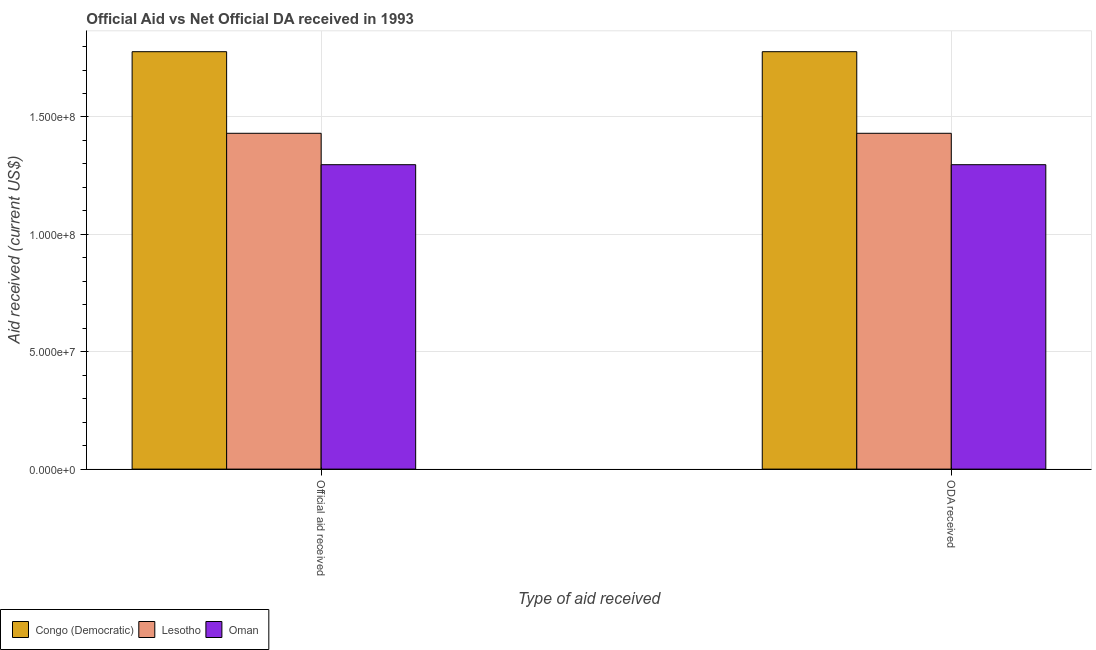How many different coloured bars are there?
Ensure brevity in your answer.  3. Are the number of bars on each tick of the X-axis equal?
Keep it short and to the point. Yes. How many bars are there on the 1st tick from the right?
Your response must be concise. 3. What is the label of the 1st group of bars from the left?
Your response must be concise. Official aid received. What is the official aid received in Oman?
Ensure brevity in your answer.  1.30e+08. Across all countries, what is the maximum oda received?
Give a very brief answer. 1.78e+08. Across all countries, what is the minimum oda received?
Keep it short and to the point. 1.30e+08. In which country was the oda received maximum?
Provide a short and direct response. Congo (Democratic). In which country was the official aid received minimum?
Your answer should be compact. Oman. What is the total oda received in the graph?
Your answer should be very brief. 4.51e+08. What is the difference between the oda received in Oman and that in Lesotho?
Provide a succinct answer. -1.34e+07. What is the difference between the oda received in Lesotho and the official aid received in Oman?
Provide a short and direct response. 1.34e+07. What is the average official aid received per country?
Your answer should be very brief. 1.50e+08. In how many countries, is the oda received greater than 140000000 US$?
Offer a very short reply. 2. What is the ratio of the official aid received in Lesotho to that in Oman?
Your answer should be compact. 1.1. Is the official aid received in Congo (Democratic) less than that in Lesotho?
Your answer should be compact. No. What does the 1st bar from the left in Official aid received represents?
Offer a very short reply. Congo (Democratic). What does the 3rd bar from the right in ODA received represents?
Provide a succinct answer. Congo (Democratic). How many bars are there?
Offer a very short reply. 6. Are all the bars in the graph horizontal?
Provide a succinct answer. No. How many countries are there in the graph?
Ensure brevity in your answer.  3. Are the values on the major ticks of Y-axis written in scientific E-notation?
Your answer should be very brief. Yes. Does the graph contain any zero values?
Your response must be concise. No. Does the graph contain grids?
Give a very brief answer. Yes. How many legend labels are there?
Keep it short and to the point. 3. What is the title of the graph?
Your answer should be compact. Official Aid vs Net Official DA received in 1993 . What is the label or title of the X-axis?
Provide a short and direct response. Type of aid received. What is the label or title of the Y-axis?
Provide a succinct answer. Aid received (current US$). What is the Aid received (current US$) in Congo (Democratic) in Official aid received?
Make the answer very short. 1.78e+08. What is the Aid received (current US$) in Lesotho in Official aid received?
Give a very brief answer. 1.43e+08. What is the Aid received (current US$) in Oman in Official aid received?
Provide a short and direct response. 1.30e+08. What is the Aid received (current US$) of Congo (Democratic) in ODA received?
Provide a short and direct response. 1.78e+08. What is the Aid received (current US$) in Lesotho in ODA received?
Provide a succinct answer. 1.43e+08. What is the Aid received (current US$) in Oman in ODA received?
Ensure brevity in your answer.  1.30e+08. Across all Type of aid received, what is the maximum Aid received (current US$) of Congo (Democratic)?
Provide a short and direct response. 1.78e+08. Across all Type of aid received, what is the maximum Aid received (current US$) in Lesotho?
Ensure brevity in your answer.  1.43e+08. Across all Type of aid received, what is the maximum Aid received (current US$) in Oman?
Keep it short and to the point. 1.30e+08. Across all Type of aid received, what is the minimum Aid received (current US$) of Congo (Democratic)?
Your answer should be compact. 1.78e+08. Across all Type of aid received, what is the minimum Aid received (current US$) in Lesotho?
Your response must be concise. 1.43e+08. Across all Type of aid received, what is the minimum Aid received (current US$) of Oman?
Your answer should be compact. 1.30e+08. What is the total Aid received (current US$) of Congo (Democratic) in the graph?
Provide a succinct answer. 3.56e+08. What is the total Aid received (current US$) of Lesotho in the graph?
Make the answer very short. 2.86e+08. What is the total Aid received (current US$) of Oman in the graph?
Your response must be concise. 2.59e+08. What is the difference between the Aid received (current US$) of Lesotho in Official aid received and that in ODA received?
Your answer should be compact. 0. What is the difference between the Aid received (current US$) of Congo (Democratic) in Official aid received and the Aid received (current US$) of Lesotho in ODA received?
Provide a short and direct response. 3.48e+07. What is the difference between the Aid received (current US$) of Congo (Democratic) in Official aid received and the Aid received (current US$) of Oman in ODA received?
Provide a short and direct response. 4.81e+07. What is the difference between the Aid received (current US$) in Lesotho in Official aid received and the Aid received (current US$) in Oman in ODA received?
Your response must be concise. 1.34e+07. What is the average Aid received (current US$) of Congo (Democratic) per Type of aid received?
Give a very brief answer. 1.78e+08. What is the average Aid received (current US$) of Lesotho per Type of aid received?
Offer a terse response. 1.43e+08. What is the average Aid received (current US$) in Oman per Type of aid received?
Keep it short and to the point. 1.30e+08. What is the difference between the Aid received (current US$) in Congo (Democratic) and Aid received (current US$) in Lesotho in Official aid received?
Ensure brevity in your answer.  3.48e+07. What is the difference between the Aid received (current US$) in Congo (Democratic) and Aid received (current US$) in Oman in Official aid received?
Your answer should be compact. 4.81e+07. What is the difference between the Aid received (current US$) of Lesotho and Aid received (current US$) of Oman in Official aid received?
Provide a short and direct response. 1.34e+07. What is the difference between the Aid received (current US$) in Congo (Democratic) and Aid received (current US$) in Lesotho in ODA received?
Your response must be concise. 3.48e+07. What is the difference between the Aid received (current US$) of Congo (Democratic) and Aid received (current US$) of Oman in ODA received?
Offer a very short reply. 4.81e+07. What is the difference between the Aid received (current US$) of Lesotho and Aid received (current US$) of Oman in ODA received?
Your response must be concise. 1.34e+07. What is the ratio of the Aid received (current US$) in Congo (Democratic) in Official aid received to that in ODA received?
Provide a short and direct response. 1. What is the ratio of the Aid received (current US$) of Oman in Official aid received to that in ODA received?
Offer a very short reply. 1. What is the difference between the highest and the second highest Aid received (current US$) of Congo (Democratic)?
Your response must be concise. 0. What is the difference between the highest and the second highest Aid received (current US$) in Lesotho?
Give a very brief answer. 0. What is the difference between the highest and the second highest Aid received (current US$) in Oman?
Ensure brevity in your answer.  0. What is the difference between the highest and the lowest Aid received (current US$) of Congo (Democratic)?
Ensure brevity in your answer.  0. What is the difference between the highest and the lowest Aid received (current US$) of Oman?
Give a very brief answer. 0. 